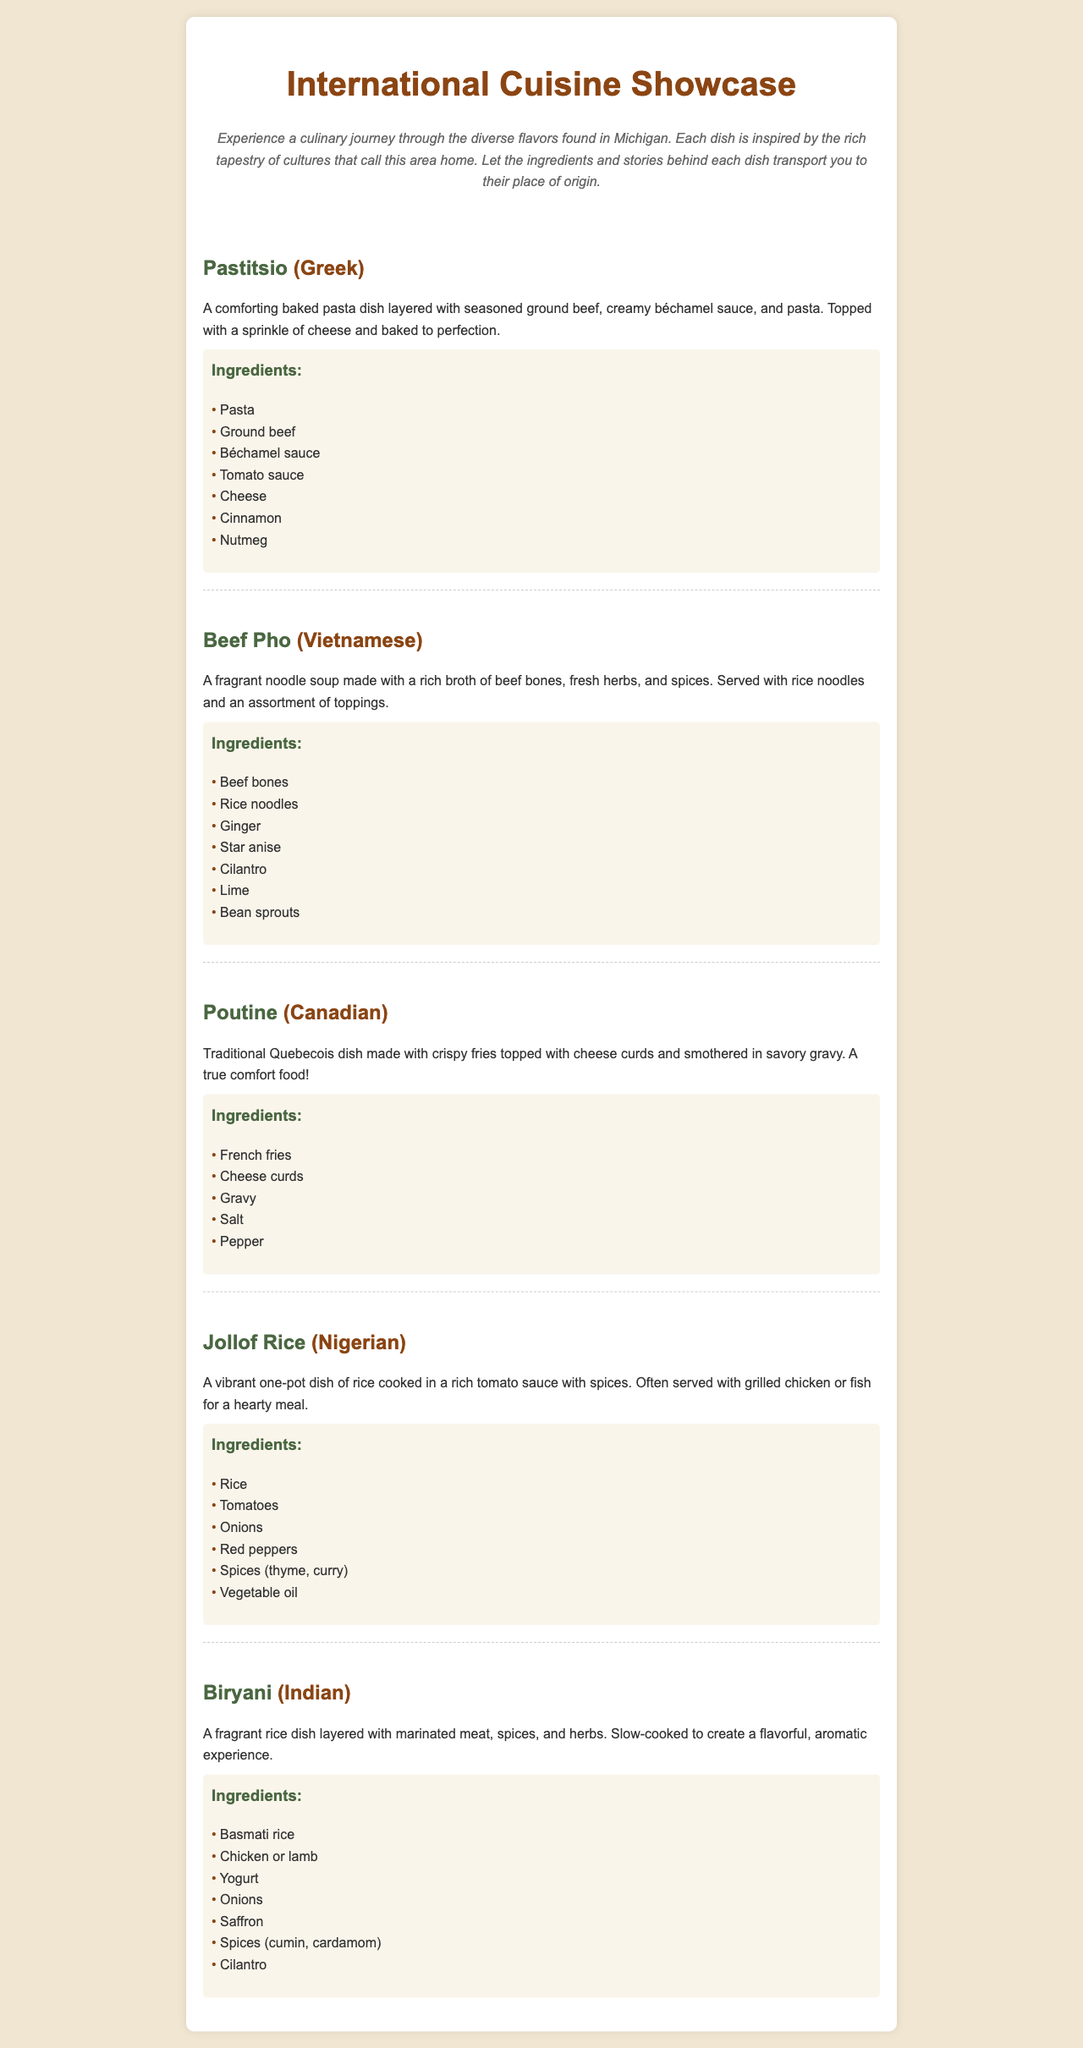What is the first dish listed? The document presents the dishes in a specific order, with "Pastitsio" as the first one.
Answer: Pastitsio How many ingredients are in the Beef Pho? The "Beef Pho" section lists 7 specific ingredients that make up the dish.
Answer: 7 Which dish contains cheese curds? The “Poutine” section describes a dish that specifically includes cheese curds among its ingredients.
Answer: Poutine What cuisine does Jollof Rice belong to? The cuisine is mentioned directly next to the dish name “Jollof Rice” in the document.
Answer: Nigerian What is a key ingredient in Biryani? The "Biryani" dish mentions "Basmati rice", which is a key ingredient for this dish.
Answer: Basmati rice Estimate the number of different cuisines featured. The document lists a total of 5 dishes, each corresponding to a different cuisine, indicating their diversity.
Answer: 5 What type of dish is Poutine? The description provided for Poutine identifies it as a traditional Quebecois dish.
Answer: Traditional Quebecois dish What herb is commonly used in both Pho and Biryani? The ingredients of both dishes include "cilantro", showing its common use in these cuisines.
Answer: Cilantro What cooking method is suggested for the Jollof Rice? The "Jollof Rice" description indicates that it is a one-pot dish, implying a specific cooking method.
Answer: One-pot dish 